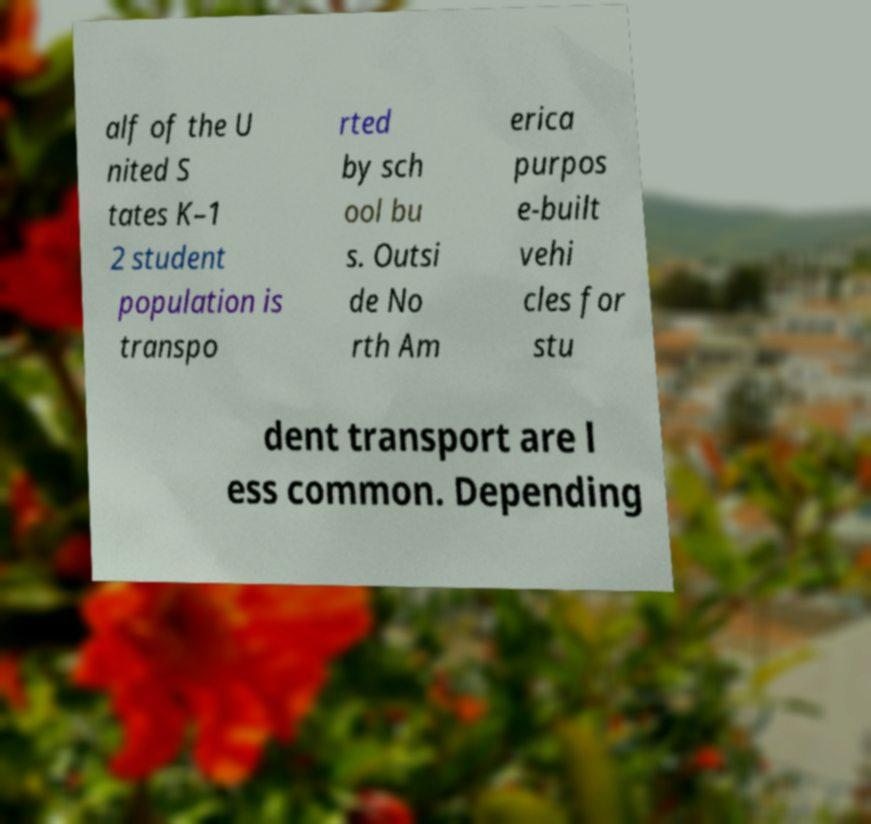Could you extract and type out the text from this image? alf of the U nited S tates K–1 2 student population is transpo rted by sch ool bu s. Outsi de No rth Am erica purpos e-built vehi cles for stu dent transport are l ess common. Depending 